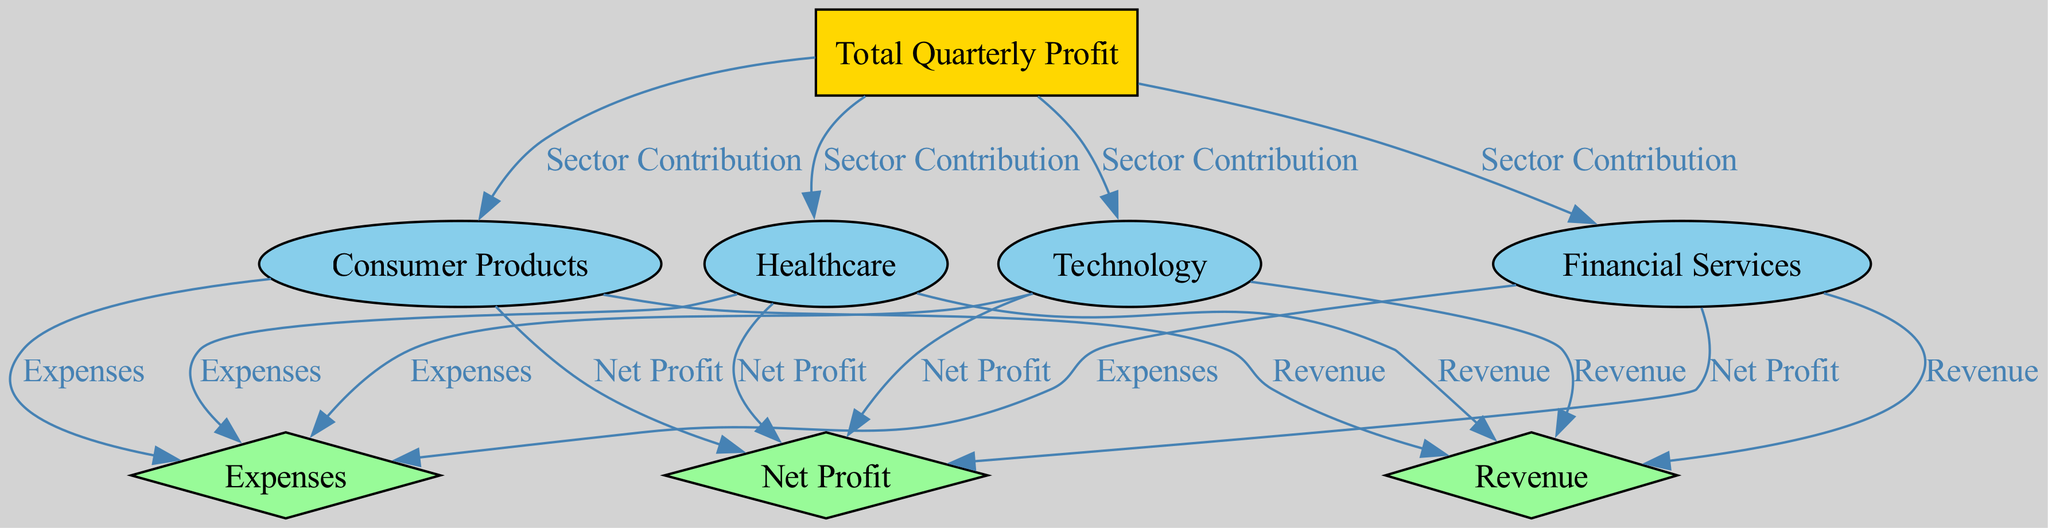What are the four sectors contributing to the total quarterly profit? The sectors are identified as nodes in the diagram connected to the root node (Total Quarterly Profit). These sectors are Consumer Products, Healthcare, Technology, and Financial Services.
Answer: Consumer Products, Healthcare, Technology, Financial Services How many nodes are present in the diagram? To answer this, we count all unique labels present in the given nodes, which include the total profit node, the four sectors, and the three metrics. This totals up to eight nodes.
Answer: 8 What type of relationship exists between each sector and the total quarterly profit? Each sector is linked to the total quarterly profit with the same label "Sector Contribution", indicating that they all contribute towards the total profit.
Answer: Sector Contribution Which metric is linked to Consumer Products? The metrics connected to Consumer Products include Revenue, Expenses, and Net Profit. As the question asks for a specific metric related to Consumer Products, we could focus on any one of these, but they are all connected.
Answer: Revenue, Expenses, Net Profit What is the type of the node "Healthcare"? The node representing Healthcare is classified as a sector based on its type data in the node list, which denotes nodes associated with specific market areas.
Answer: sector If the total quarterly profit increases, what is the expected trend for the linked sectors? If the total quarterly profit increases, it implies that either revenue from the sectors must increase, expenses must decrease, or both. Since the sectors are directly contributing, we can state that an increase is expected across the sectors in terms of contribution.
Answer: Increase Which metric has the most direct effect on Net Profit for each sector? The most direct effect on Net Profit for each sector comes from the relationship established in the diagram, specifically from the Revenue and Expenses metrics. Net Profit is calculated as Revenue minus Expenses.
Answer: Revenue, Expenses How many edges are connecting the Revenue of the sectors to the Total Quarterly Profit? For each sector, there is one edge representing the Revenue metrics linked to Total Quarterly Profit, leading to the total edges connecting Revenues being equal to the number of sectors. Since there are four sectors, there will be four edges.
Answer: 4 